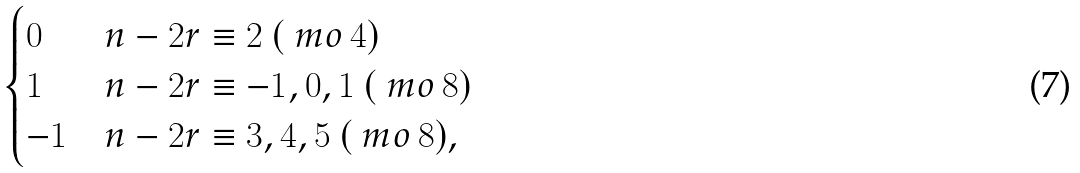<formula> <loc_0><loc_0><loc_500><loc_500>\begin{cases} 0 & n - 2 r \equiv 2 \ ( \ m o \, 4 ) \\ 1 & n - 2 r \equiv - 1 , 0 , 1 \ ( \ m o \, 8 ) \\ - 1 & n - 2 r \equiv 3 , 4 , 5 \ ( \ m o \, 8 ) , \end{cases}</formula> 